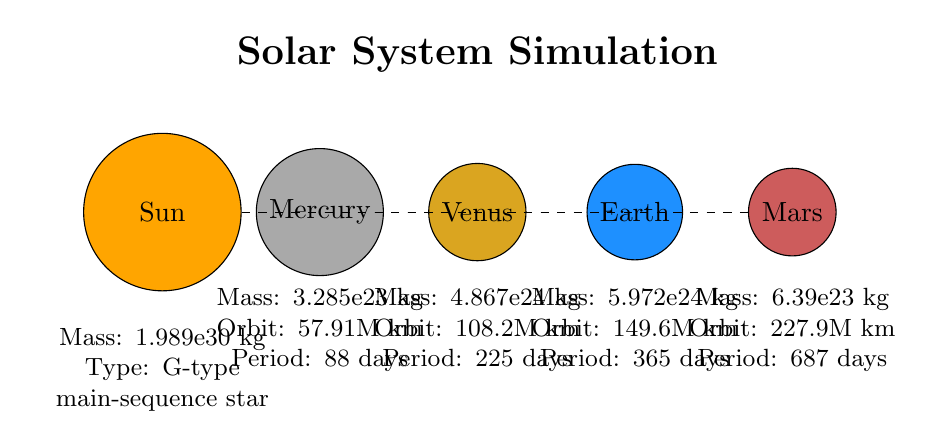What is the mass of Mercury? In the diagram, the information for Mercury is located in the label below the Mercury node, which states "Mass: 3.285e23 kg." Thus, extracting the mass value directly from the label gives us the answer.
Answer: 3.285e23 kg How many planets are shown in the diagram? The diagram includes nodes for four planets: Mercury, Venus, Earth, and Mars. By counting the visual representations of the planets, we can confirm there are four.
Answer: 4 Which planet has the longest orbital period? The labels indicate each planet's orbital period. The periods are 88 days for Mercury, 225 days for Venus, 365 days for Earth, and 687 days for Mars. Comparing these values, we see that Mars has the longest period of 687 days.
Answer: Mars What type of star is the Sun? The label under the Sun node indicates its type as "G-type main-sequence star". To answer the question, we look directly at the properties listed for the Sun in the diagram.
Answer: G-type main-sequence star What is the distance of Earth from the Sun? The diagram provides the Earth label with an orbital distance of "149.6M km" below it. By directly referencing the information shown, we can answer the question accurately.
Answer: 149.6M km Which planet is closest to the Sun? The positions of the planets relative to the Sun indicate proximity. Mercury is the first planet listed and is therefore the closest to the Sun, which can be confirmed by its position in the diagram.
Answer: Mercury What is the mass of the Sun? The Sun's mass details are given under its node in the diagram, stating "Mass: 1.989e30 kg." Simply reading this portion of the diagram allows us to answer the question.
Answer: 1.989e30 kg Which planet is furthest from the Sun? By evaluating the positions of the planets in the diagram, we see that Mars is placed last among the four planets depicted, indicating it is the furthest from the Sun.
Answer: Mars 